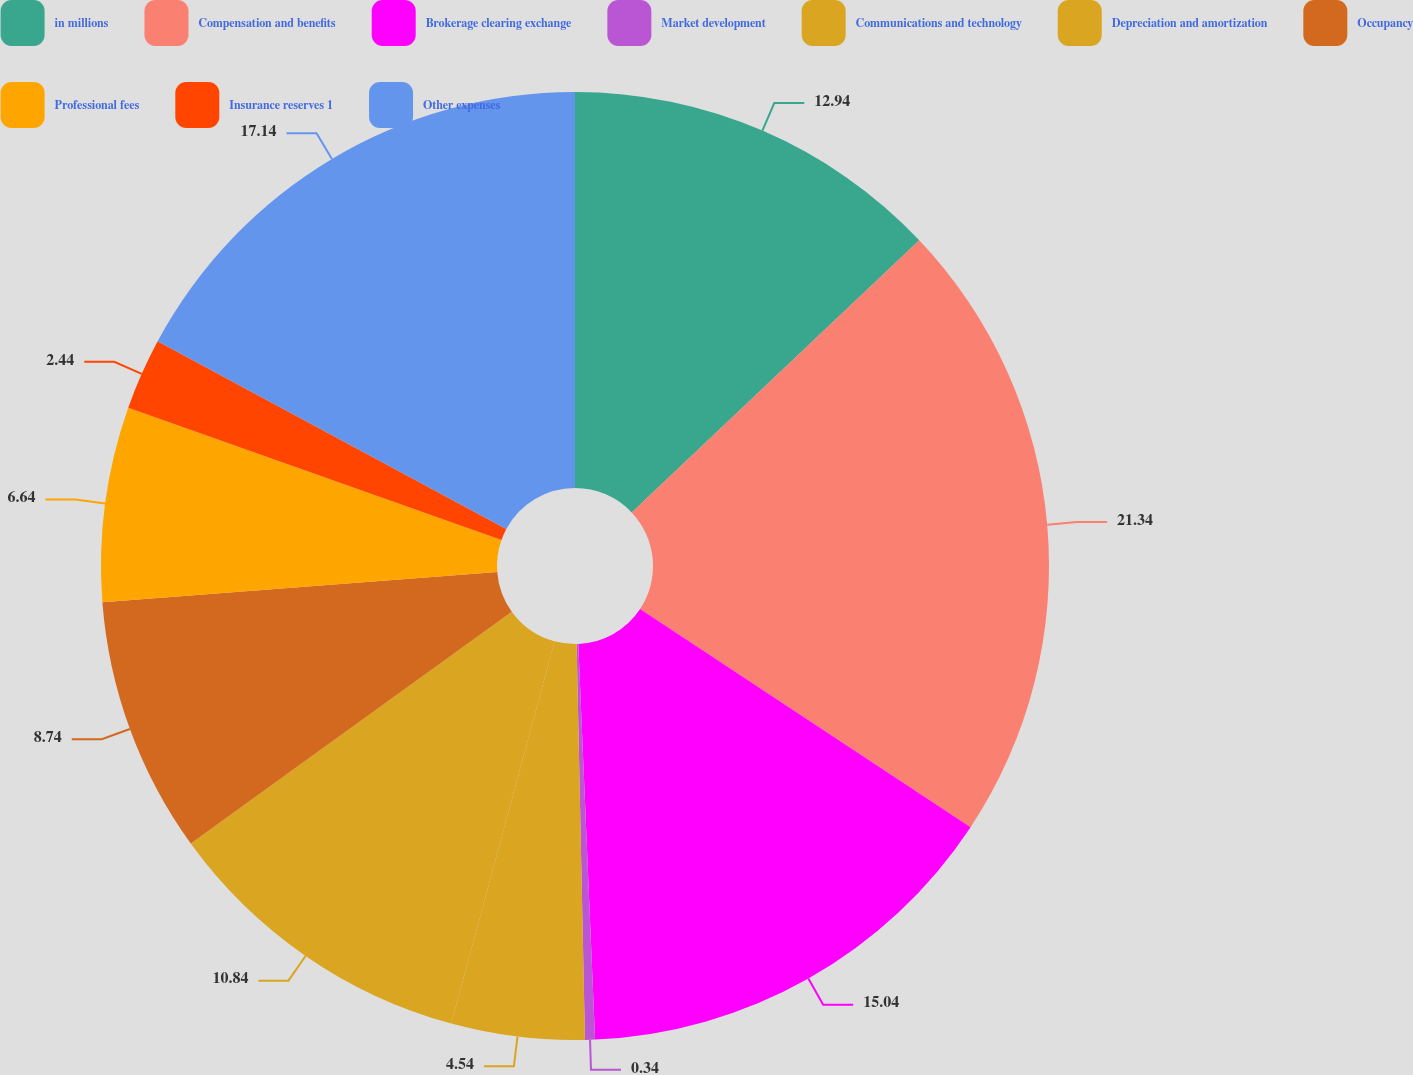Convert chart. <chart><loc_0><loc_0><loc_500><loc_500><pie_chart><fcel>in millions<fcel>Compensation and benefits<fcel>Brokerage clearing exchange<fcel>Market development<fcel>Communications and technology<fcel>Depreciation and amortization<fcel>Occupancy<fcel>Professional fees<fcel>Insurance reserves 1<fcel>Other expenses<nl><fcel>12.94%<fcel>21.35%<fcel>15.04%<fcel>0.34%<fcel>4.54%<fcel>10.84%<fcel>8.74%<fcel>6.64%<fcel>2.44%<fcel>17.14%<nl></chart> 